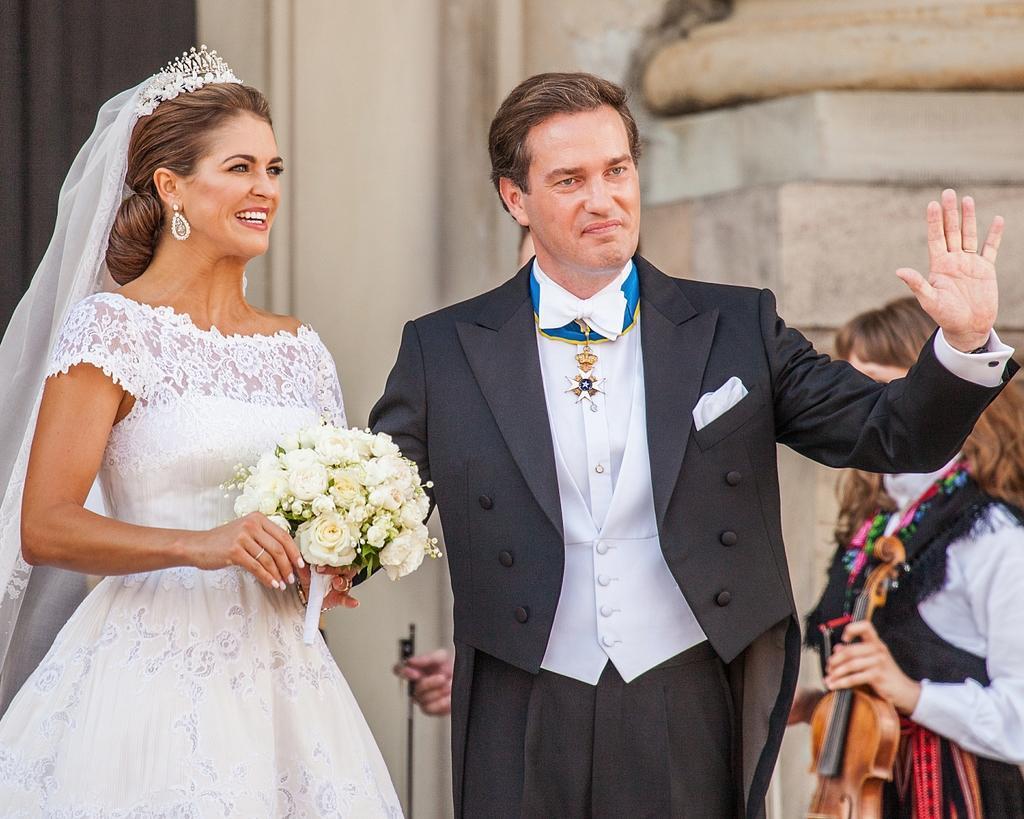Please provide a concise description of this image. In this image we can see man and woman standing on the ground holding bouquet. In the background we can see women and building. 